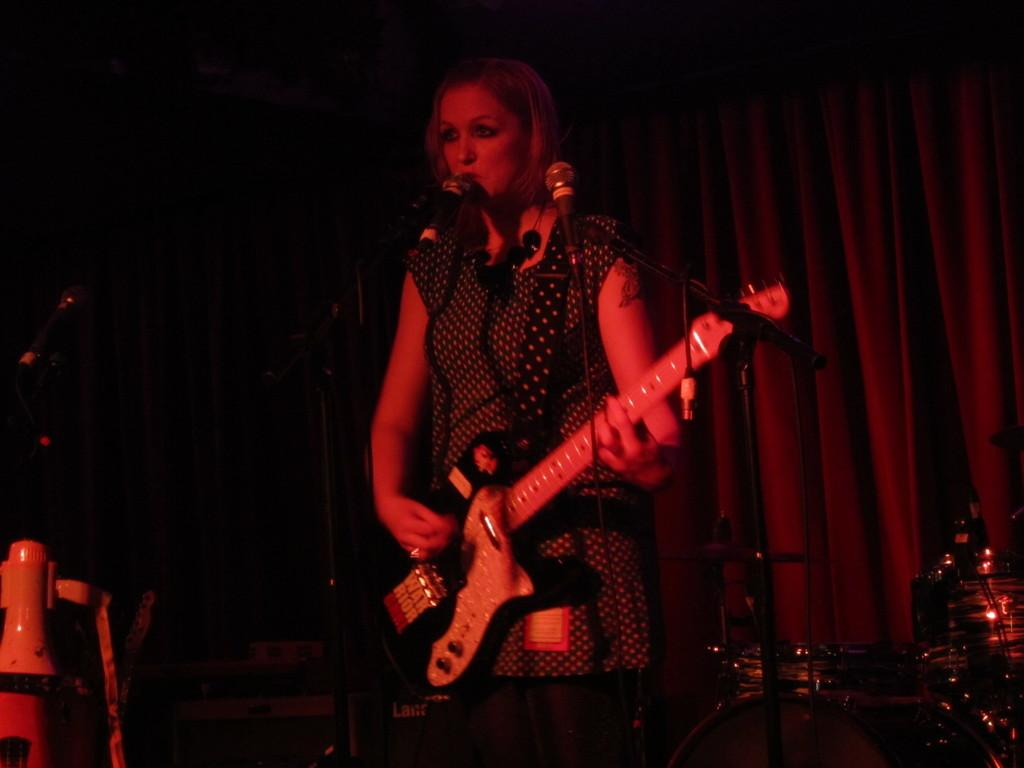What is the lady in the image doing? The lady is playing a guitar and singing. What musical instruments are visible in the image? There are microphones in front of the lady and drums beside her. What can be seen in the background of the image? There is a curtain in the background of the image. What type of vegetable is being used as a prop in the image? There is no vegetable present in the image. How does the lady control the volume of her singing in the image? The image does not show any controls for adjusting the volume of the lady's singing. 